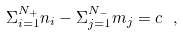Convert formula to latex. <formula><loc_0><loc_0><loc_500><loc_500>\Sigma _ { i = 1 } ^ { N _ { + } } n _ { i } - \Sigma _ { j = 1 } ^ { N _ { - } } m _ { j } = c \ ,</formula> 